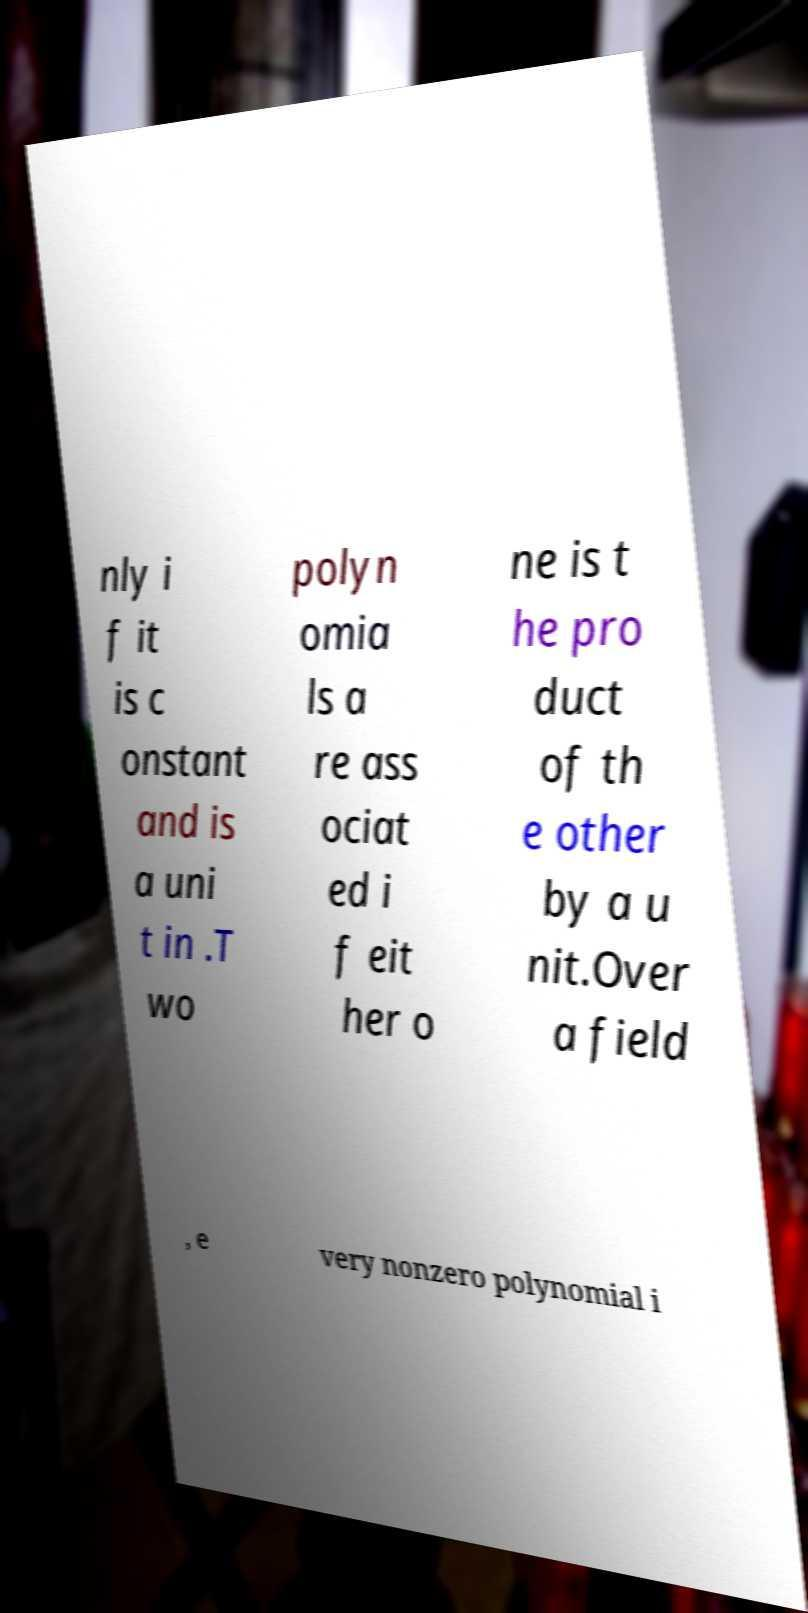What messages or text are displayed in this image? I need them in a readable, typed format. nly i f it is c onstant and is a uni t in .T wo polyn omia ls a re ass ociat ed i f eit her o ne is t he pro duct of th e other by a u nit.Over a field , e very nonzero polynomial i 